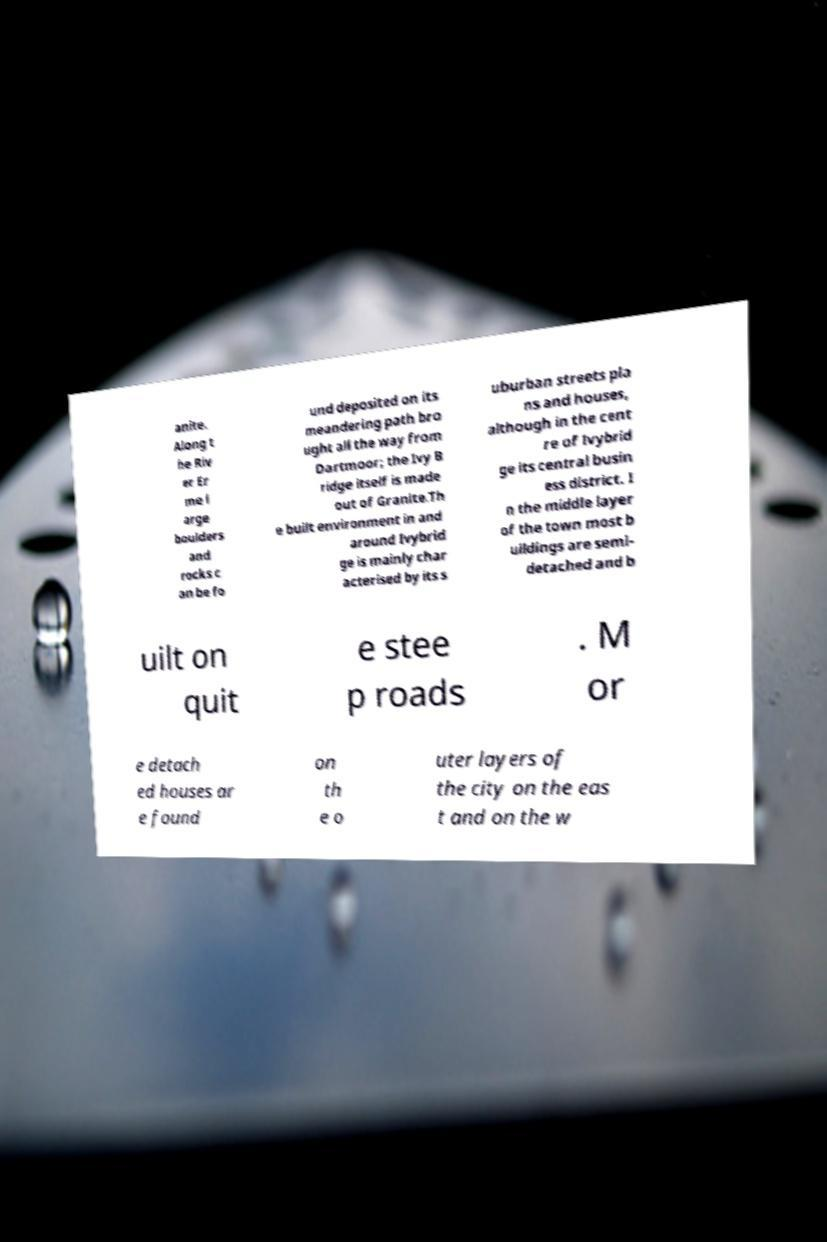For documentation purposes, I need the text within this image transcribed. Could you provide that? anite. Along t he Riv er Er me l arge boulders and rocks c an be fo und deposited on its meandering path bro ught all the way from Dartmoor; the Ivy B ridge itself is made out of Granite.Th e built environment in and around Ivybrid ge is mainly char acterised by its s uburban streets pla ns and houses, although in the cent re of Ivybrid ge its central busin ess district. I n the middle layer of the town most b uildings are semi- detached and b uilt on quit e stee p roads . M or e detach ed houses ar e found on th e o uter layers of the city on the eas t and on the w 